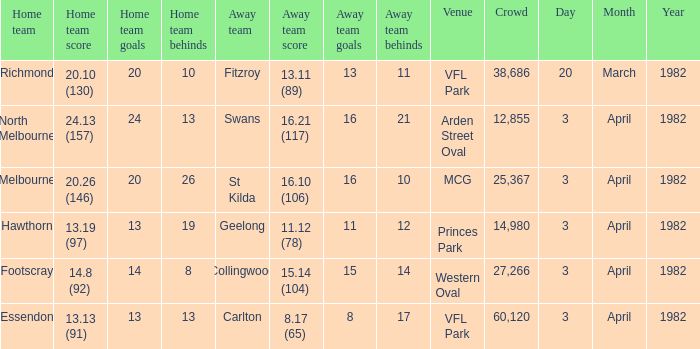When the away team scored 16.21 (117), what was the home teams score? 24.13 (157). Can you give me this table as a dict? {'header': ['Home team', 'Home team score', 'Home team goals', 'Home team behinds', 'Away team', 'Away team score', 'Away team goals', 'Away team behinds', 'Venue', 'Crowd', 'Day', 'Month', 'Year'], 'rows': [['Richmond', '20.10 (130)', '20', '10', 'Fitzroy', '13.11 (89)', '13', '11', 'VFL Park', '38,686', '20', 'March', '1982'], ['North Melbourne', '24.13 (157)', '24', '13', 'Swans', '16.21 (117)', '16', '21', 'Arden Street Oval', '12,855', '3', 'April', '1982'], ['Melbourne', '20.26 (146)', '20', '26', 'St Kilda', '16.10 (106)', '16', '10', 'MCG', '25,367', '3', 'April', '1982'], ['Hawthorn', '13.19 (97)', '13', '19', 'Geelong', '11.12 (78)', '11', '12', 'Princes Park', '14,980', '3', 'April', '1982'], ['Footscray', '14.8 (92)', '14', '8', 'Collingwood', '15.14 (104)', '15', '14', 'Western Oval', '27,266', '3', 'April', '1982'], ['Essendon', '13.13 (91)', '13', '13', 'Carlton', '8.17 (65)', '8', '17', 'VFL Park', '60,120', '3', 'April', '1982']]} 